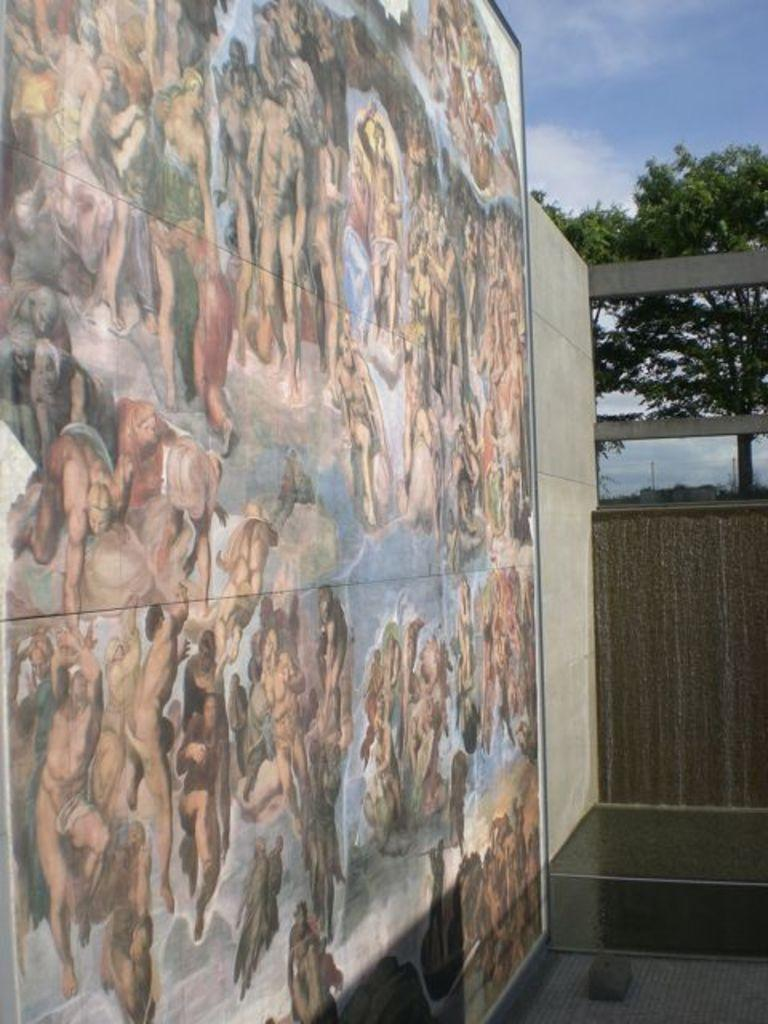What is attached to the wall in the image? There is a painting attached to the wall in the image. What can be seen on the right side of the image? A tree is present on the right side of the image boundary. What is visible in the image besides the painting and the tree? The sky is visible in the image. What is the color of the sky in the image? The color of the sky is blue. What type of reaction does the cart have to the blade in the image? There is no cart or blade present in the image, so it is not possible to answer that question. 